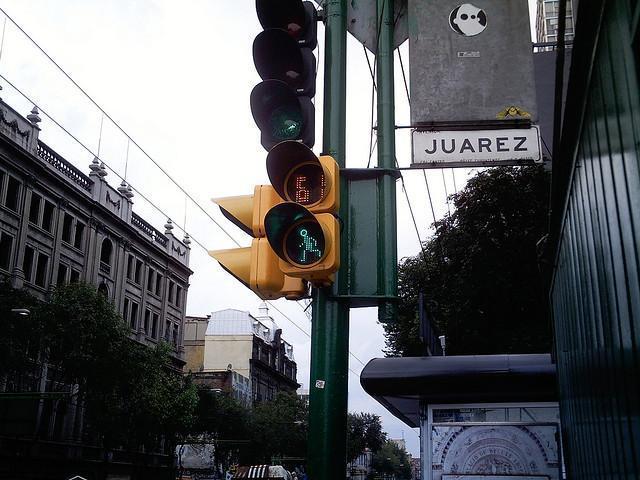How many power lines are overhead?
Give a very brief answer. 6. How many traffic lights are there?
Give a very brief answer. 2. 